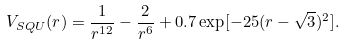Convert formula to latex. <formula><loc_0><loc_0><loc_500><loc_500>V _ { S Q U } ( r ) = \frac { 1 } { r ^ { 1 2 } } - \frac { 2 } { r ^ { 6 } } + 0 . 7 \exp [ - 2 5 ( r - \sqrt { 3 } ) ^ { 2 } ] .</formula> 